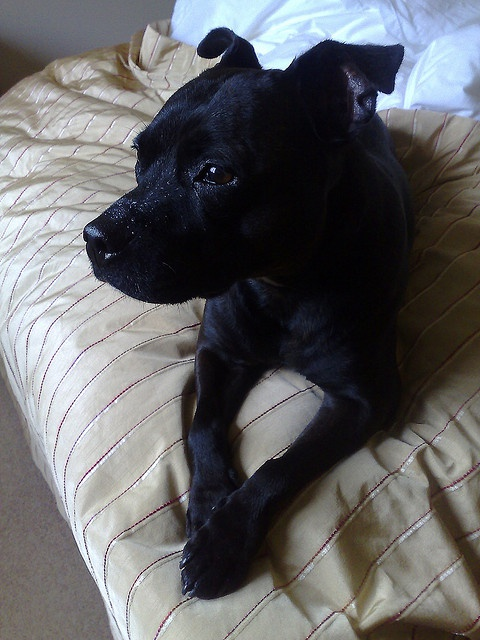Describe the objects in this image and their specific colors. I can see bed in gray, darkgray, lightgray, and black tones and dog in gray, black, darkgray, and navy tones in this image. 